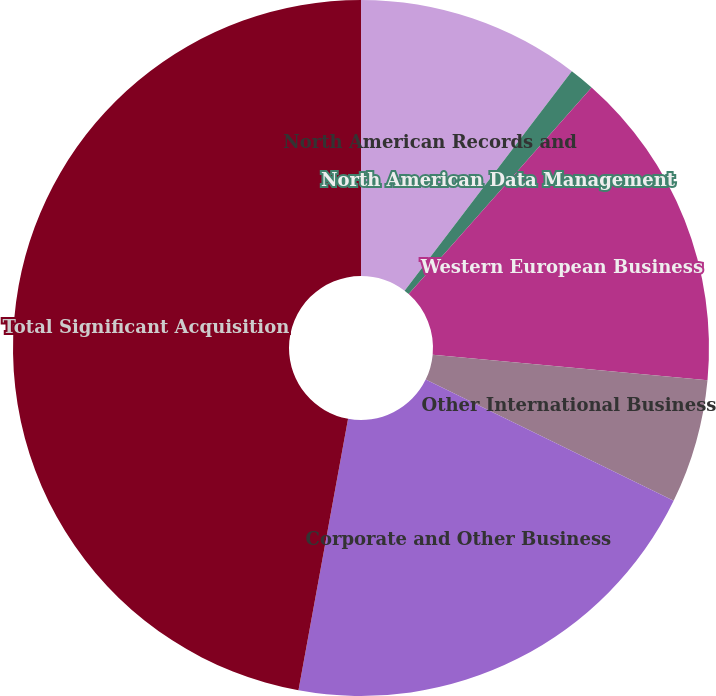Convert chart to OTSL. <chart><loc_0><loc_0><loc_500><loc_500><pie_chart><fcel>North American Records and<fcel>North American Data Management<fcel>Western European Business<fcel>Other International Business<fcel>Corporate and Other Business<fcel>Total Significant Acquisition<nl><fcel>10.36%<fcel>1.17%<fcel>14.95%<fcel>5.76%<fcel>20.64%<fcel>47.13%<nl></chart> 